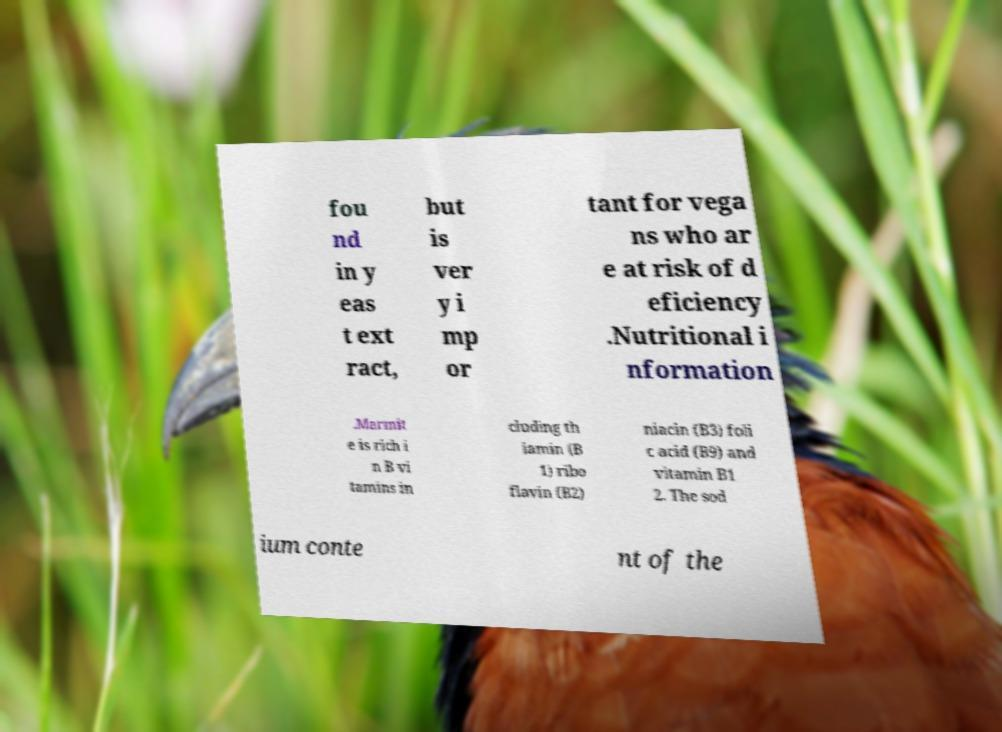Could you extract and type out the text from this image? fou nd in y eas t ext ract, but is ver y i mp or tant for vega ns who ar e at risk of d eficiency .Nutritional i nformation .Marmit e is rich i n B vi tamins in cluding th iamin (B 1) ribo flavin (B2) niacin (B3) foli c acid (B9) and vitamin B1 2. The sod ium conte nt of the 